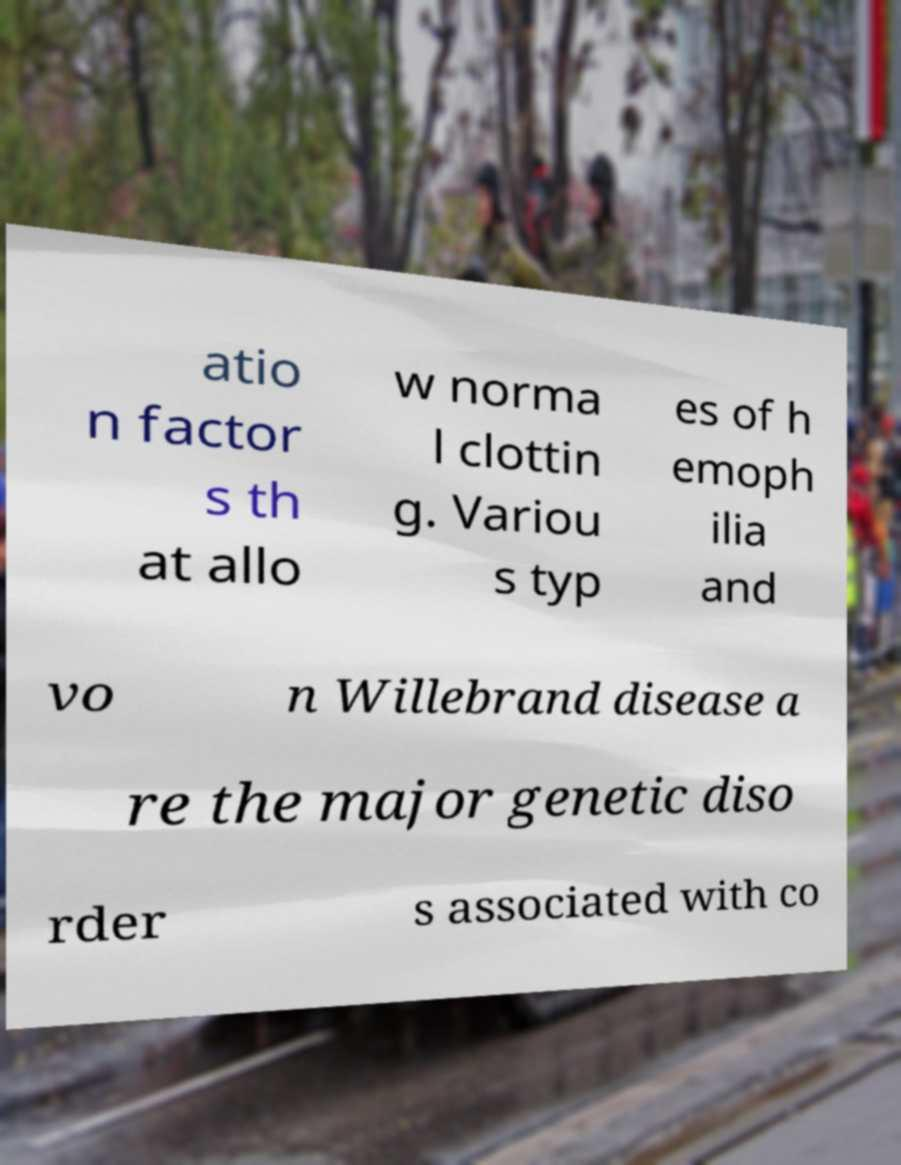Please identify and transcribe the text found in this image. atio n factor s th at allo w norma l clottin g. Variou s typ es of h emoph ilia and vo n Willebrand disease a re the major genetic diso rder s associated with co 